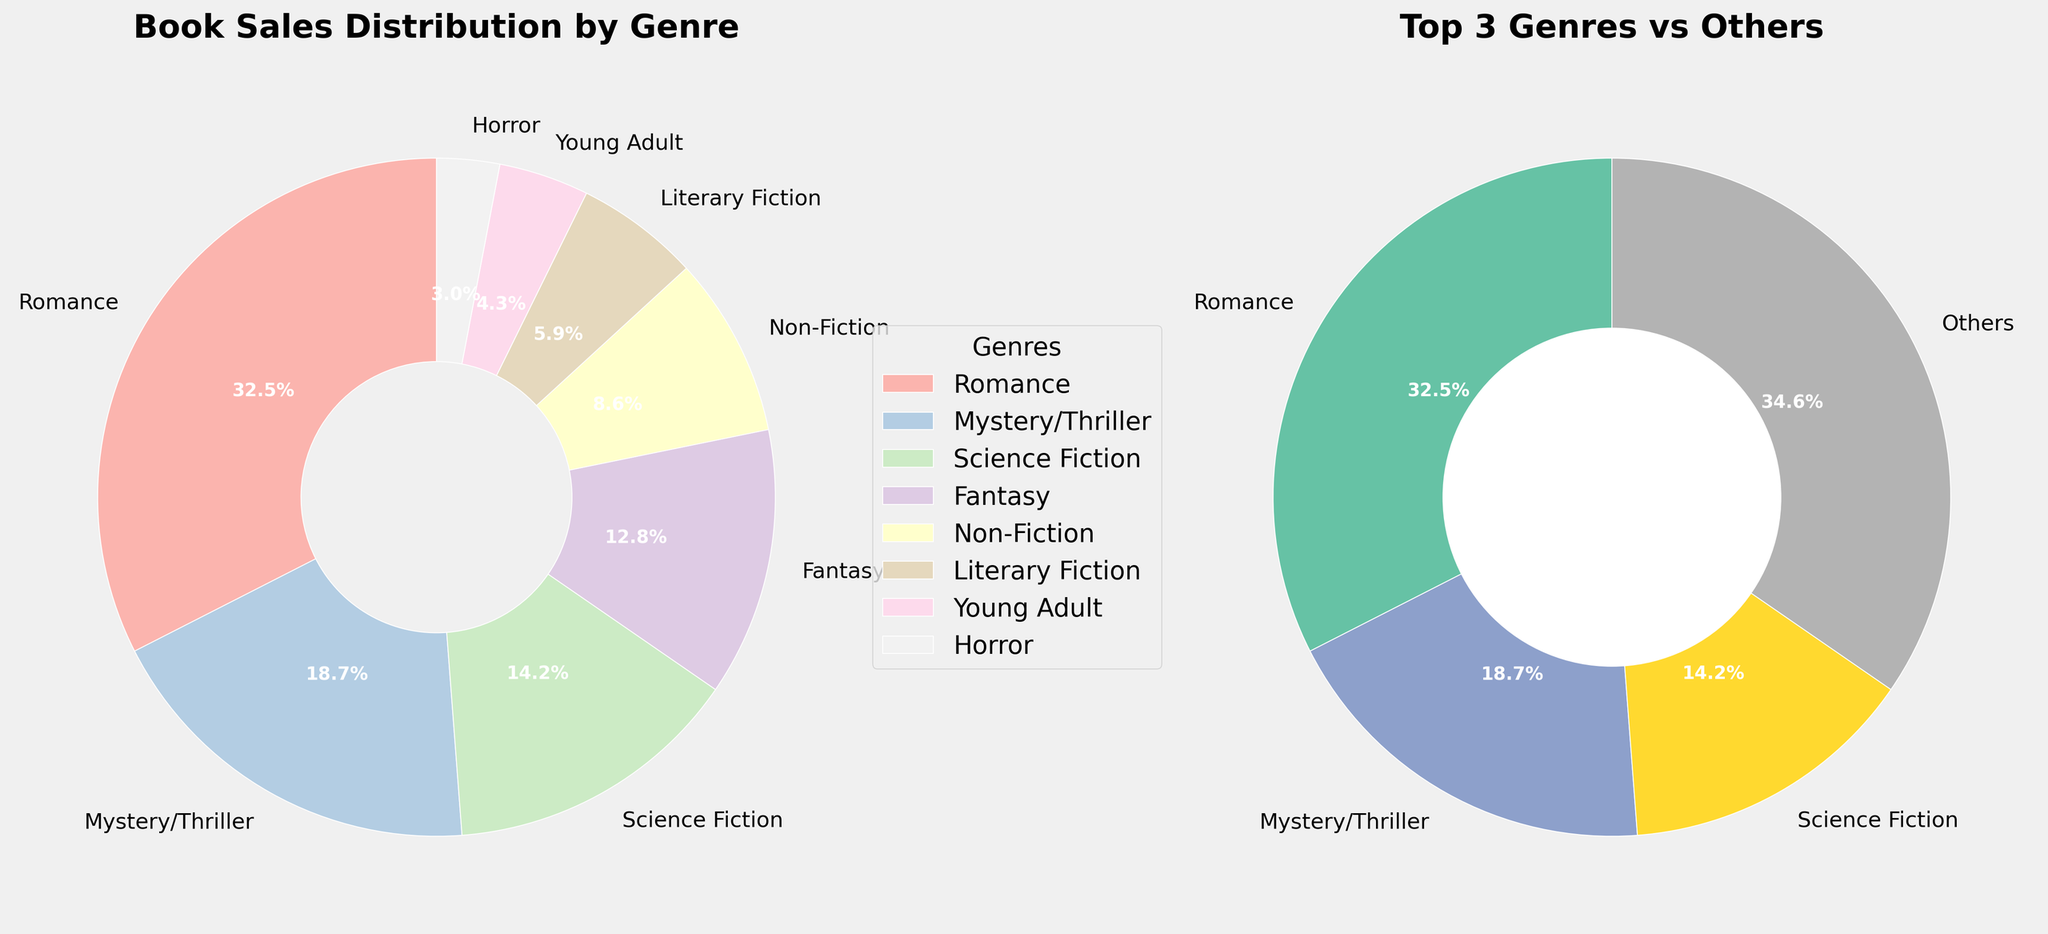What is the genre with the highest sales percentage in the main pie chart? The genre with the highest sales percentage can be identified by the largest slice in the pie chart. In the main pie chart, Romance has the largest slice, labeled as 32.5%.
Answer: Romance What is the total combined sales percentage of Science Fiction and Fantasy? To find the total combined sales percentage of Science Fiction and Fantasy, sum their individual percentages from the main pie chart. Science Fiction has 14.2%, and Fantasy has 12.8%. Adding them gives 14.2% + 12.8% = 27%.
Answer: 27% Which genre has a higher sales percentage: Mystery/Thriller or Non-Fiction? Compare the individual sales percentages of Mystery/Thriller and Non-Fiction from the main pie chart. Mystery/Thriller has 18.7% and Non-Fiction has 8.6%. Thus, Mystery/Thriller has a higher sales percentage.
Answer: Mystery/Thriller What are the titles of the two charts in the figure? The titles of the charts are located at the top of each subplot. The first chart is titled "Book Sales Distribution by Genre," and the second chart is titled "Top 3 Genres vs Others."
Answer: "Book Sales Distribution by Genre" and "Top 3 Genres vs Others" What percentage of book sales do the top 3 genres (from the donut chart) represent? To find the combined sales percentage of the top 3 genres, sum their individual percentages from the donut chart. Romance has 32.5%, Mystery/Thriller has 18.7%, and Science Fiction has 14.2%. The total is 32.5% + 18.7% + 14.2% = 65.4%.
Answer: 65.4% Which genre appears in both the main pie chart and the donut chart? Identify a genre that appears in both charts. The main pie chart contains all genres, and the donut chart represents the top 3 genres and 'Others.' Romance, Mystery/Thriller, and Science Fiction appear in both charts.
Answer: Romance, Mystery/Thriller, Science Fiction How does the sales percentage of 'Others' compare to the sales percentage of Young Adult in the donut chart? 'Others' in the donut chart is the combined percentage of all genres excluding the top 3. Young Adult in the main pie chart has 4.3%. 'Others' in the donut chart is 34.6%. Therefore, 'Others' has a higher sales percentage.
Answer: 'Others' is higher Explain the reasoning behind creating a donut chart for the top 3 genres. The donut chart isolates the top 3 genres to emphasize their dominance and makes it easier to compare the most successful genres against the rest of the genres grouped as 'Others.' This provides clearer insight into how much the top genres contribute to overall sales.
Answer: Isolates top 3 genres for emphasis and easier comparison What is the difference in sales percentage between Fantasy and Young Adult genres? To find the difference, subtract the sales percentage of Young Adult from Fantasy. Fantasy has 12.8% and Young Adult has 4.3%. The difference is 12.8% - 4.3% = 8.5%.
Answer: 8.5% What colors are used for the top 3 genres in the donut chart? In the donut chart, colors for Romance, Mystery/Thriller, and Science Fiction would typically be distinct pastel shades since the plot uses a Pastel1 colormap for the main chart and Set2 for the donut chart. Although exact shades aren't specified, they can be identified as the first three unique colors in the Set2 colormap.
Answer: Distinct pastel shades 